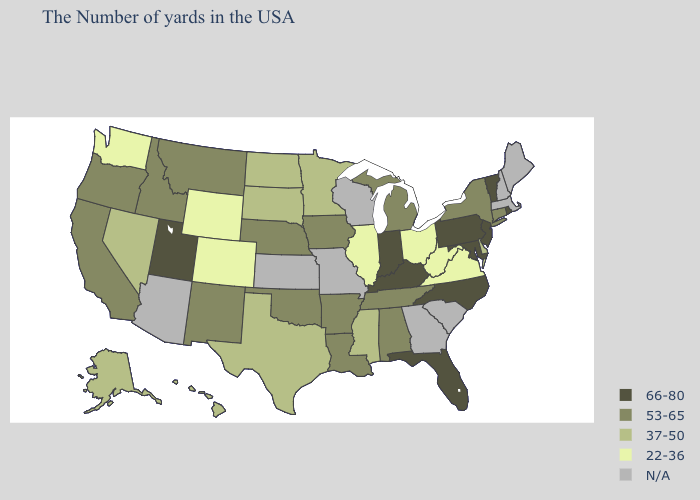Does the first symbol in the legend represent the smallest category?
Give a very brief answer. No. Name the states that have a value in the range 53-65?
Give a very brief answer. Connecticut, New York, Michigan, Alabama, Tennessee, Louisiana, Arkansas, Iowa, Nebraska, Oklahoma, New Mexico, Montana, Idaho, California, Oregon. Name the states that have a value in the range 53-65?
Give a very brief answer. Connecticut, New York, Michigan, Alabama, Tennessee, Louisiana, Arkansas, Iowa, Nebraska, Oklahoma, New Mexico, Montana, Idaho, California, Oregon. Does the first symbol in the legend represent the smallest category?
Answer briefly. No. What is the value of New York?
Be succinct. 53-65. What is the value of New Mexico?
Be succinct. 53-65. What is the lowest value in states that border Maryland?
Concise answer only. 22-36. Does Alaska have the highest value in the West?
Short answer required. No. Which states have the lowest value in the South?
Quick response, please. Virginia, West Virginia. What is the lowest value in the USA?
Answer briefly. 22-36. Name the states that have a value in the range N/A?
Short answer required. Maine, Massachusetts, New Hampshire, South Carolina, Georgia, Wisconsin, Missouri, Kansas, Arizona. What is the highest value in the South ?
Quick response, please. 66-80. What is the value of Connecticut?
Give a very brief answer. 53-65. 